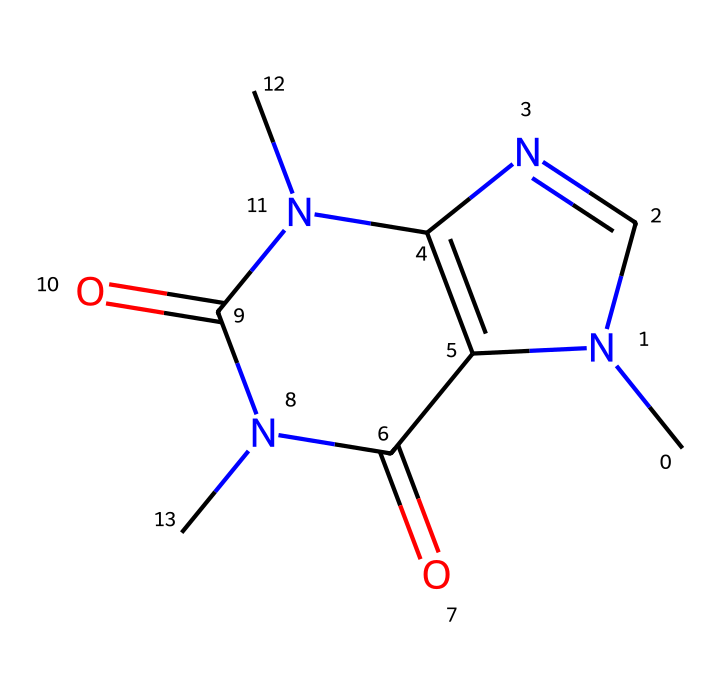What is the molecular formula of caffeine? To find the molecular formula, count the number of each type of atom present in the SMILES representation. There are 8 carbon (C) atoms, 10 hydrogen (H) atoms, 4 nitrogen (N) atoms, and 2 oxygen (O) atoms. Thus, the molecular formula is C8H10N4O2.
Answer: C8H10N4O2 How many nitrogen atoms are in caffeine? From the SMILES representation, we can see that there are 4 nitrogen (N) atoms present.
Answer: 4 What is the functional group indicated in the structure? The structure contains carbonyl groups (C=O), which are indicated by the presence of double-bonded oxygen atoms.
Answer: carbonyl Is caffeine an aromatic compound? The presence of conjugated double bonds within a cyclic structure indicates aromaticity. This compound has a combination of nitrogen atoms in a fused ring structure, suggesting it is aromatic.
Answer: yes Which part of caffeine contributes to its stimulant properties? The presence of the nitrogen atoms plays a significant role in caffeine's biological activity as a stimulant, as they are part of the alkaloid structure that interacts with adenosine receptors in the brain.
Answer: nitrogen atoms What is the total number of rings in the caffeine structure? Analyzing the structure shows that there are two fused rings present in caffeine. This is evident from the way the cyclic parts interact in the SMILES representation.
Answer: 2 What type of solvent is known to dissolve caffeine effectively? Polar solvents are typically known to dissolve caffeine effectively due to the polar nature of the molecule, primarily owing to the nitrogen and oxygen atoms.
Answer: polar solvents 